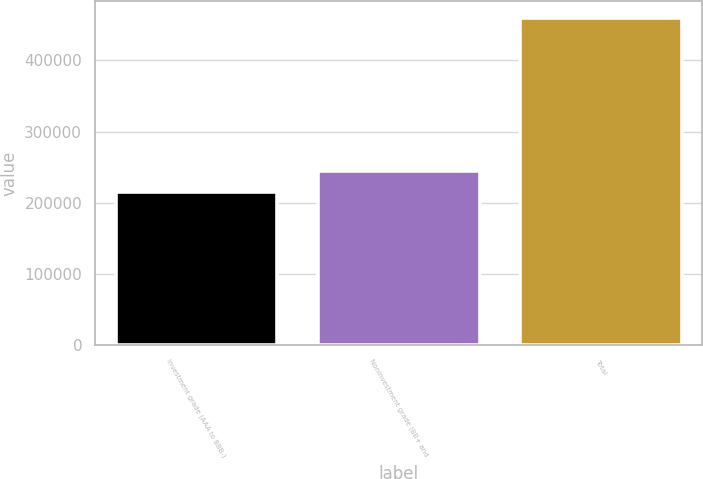<chart> <loc_0><loc_0><loc_500><loc_500><bar_chart><fcel>Investment grade (AAA to BBB-)<fcel>Noninvestment grade (BB+ and<fcel>Total<nl><fcel>215217<fcel>244975<fcel>460192<nl></chart> 